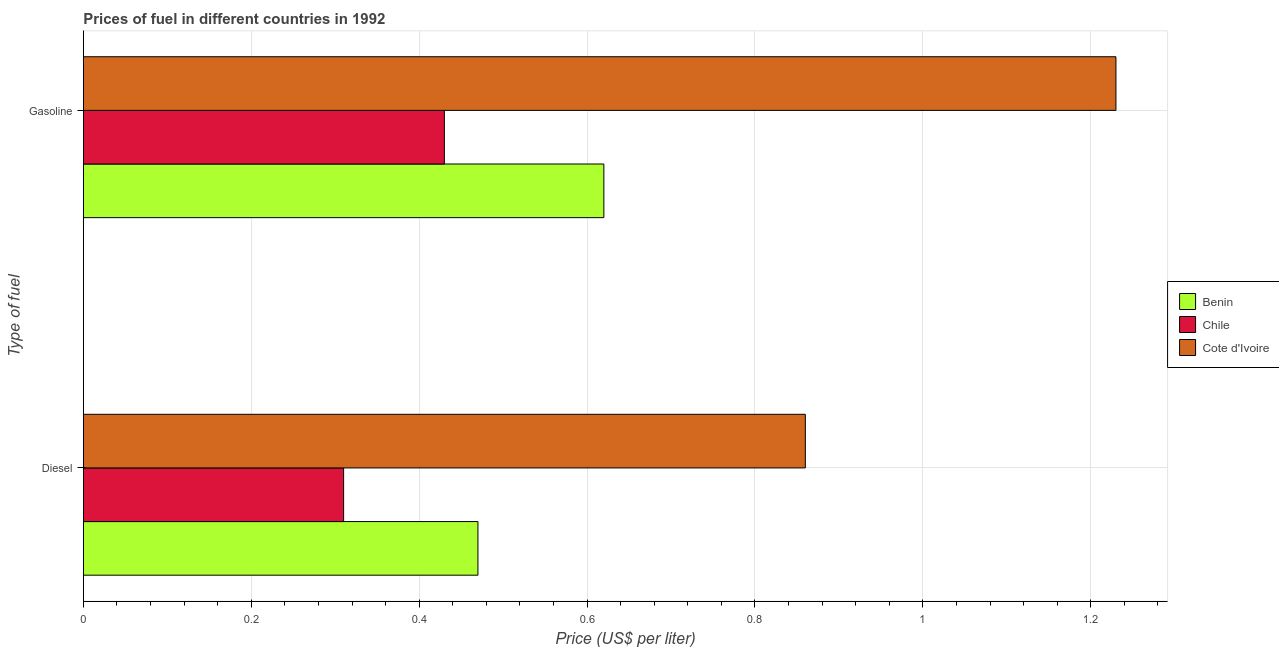How many groups of bars are there?
Make the answer very short. 2. Are the number of bars per tick equal to the number of legend labels?
Your answer should be very brief. Yes. Are the number of bars on each tick of the Y-axis equal?
Provide a succinct answer. Yes. How many bars are there on the 1st tick from the top?
Your response must be concise. 3. How many bars are there on the 1st tick from the bottom?
Give a very brief answer. 3. What is the label of the 1st group of bars from the top?
Provide a succinct answer. Gasoline. What is the gasoline price in Benin?
Provide a short and direct response. 0.62. Across all countries, what is the maximum diesel price?
Offer a terse response. 0.86. Across all countries, what is the minimum diesel price?
Offer a very short reply. 0.31. In which country was the gasoline price maximum?
Make the answer very short. Cote d'Ivoire. In which country was the diesel price minimum?
Offer a terse response. Chile. What is the total diesel price in the graph?
Keep it short and to the point. 1.64. What is the difference between the diesel price in Chile and that in Cote d'Ivoire?
Give a very brief answer. -0.55. What is the difference between the diesel price in Benin and the gasoline price in Chile?
Your response must be concise. 0.04. What is the average gasoline price per country?
Offer a very short reply. 0.76. What is the difference between the diesel price and gasoline price in Benin?
Offer a terse response. -0.15. In how many countries, is the gasoline price greater than 1 US$ per litre?
Give a very brief answer. 1. What is the ratio of the gasoline price in Benin to that in Chile?
Make the answer very short. 1.44. In how many countries, is the gasoline price greater than the average gasoline price taken over all countries?
Give a very brief answer. 1. What does the 3rd bar from the top in Diesel represents?
Provide a short and direct response. Benin. What does the 2nd bar from the bottom in Diesel represents?
Offer a very short reply. Chile. Are all the bars in the graph horizontal?
Make the answer very short. Yes. How many countries are there in the graph?
Give a very brief answer. 3. What is the difference between two consecutive major ticks on the X-axis?
Give a very brief answer. 0.2. Does the graph contain grids?
Offer a very short reply. Yes. How many legend labels are there?
Provide a succinct answer. 3. How are the legend labels stacked?
Offer a terse response. Vertical. What is the title of the graph?
Your answer should be compact. Prices of fuel in different countries in 1992. Does "Morocco" appear as one of the legend labels in the graph?
Make the answer very short. No. What is the label or title of the X-axis?
Make the answer very short. Price (US$ per liter). What is the label or title of the Y-axis?
Offer a very short reply. Type of fuel. What is the Price (US$ per liter) of Benin in Diesel?
Provide a short and direct response. 0.47. What is the Price (US$ per liter) in Chile in Diesel?
Make the answer very short. 0.31. What is the Price (US$ per liter) of Cote d'Ivoire in Diesel?
Make the answer very short. 0.86. What is the Price (US$ per liter) of Benin in Gasoline?
Keep it short and to the point. 0.62. What is the Price (US$ per liter) in Chile in Gasoline?
Offer a terse response. 0.43. What is the Price (US$ per liter) in Cote d'Ivoire in Gasoline?
Make the answer very short. 1.23. Across all Type of fuel, what is the maximum Price (US$ per liter) in Benin?
Your answer should be compact. 0.62. Across all Type of fuel, what is the maximum Price (US$ per liter) in Chile?
Make the answer very short. 0.43. Across all Type of fuel, what is the maximum Price (US$ per liter) of Cote d'Ivoire?
Keep it short and to the point. 1.23. Across all Type of fuel, what is the minimum Price (US$ per liter) of Benin?
Offer a very short reply. 0.47. Across all Type of fuel, what is the minimum Price (US$ per liter) of Chile?
Provide a short and direct response. 0.31. Across all Type of fuel, what is the minimum Price (US$ per liter) of Cote d'Ivoire?
Keep it short and to the point. 0.86. What is the total Price (US$ per liter) in Benin in the graph?
Keep it short and to the point. 1.09. What is the total Price (US$ per liter) in Chile in the graph?
Give a very brief answer. 0.74. What is the total Price (US$ per liter) in Cote d'Ivoire in the graph?
Offer a terse response. 2.09. What is the difference between the Price (US$ per liter) of Chile in Diesel and that in Gasoline?
Provide a short and direct response. -0.12. What is the difference between the Price (US$ per liter) in Cote d'Ivoire in Diesel and that in Gasoline?
Your answer should be very brief. -0.37. What is the difference between the Price (US$ per liter) in Benin in Diesel and the Price (US$ per liter) in Chile in Gasoline?
Keep it short and to the point. 0.04. What is the difference between the Price (US$ per liter) in Benin in Diesel and the Price (US$ per liter) in Cote d'Ivoire in Gasoline?
Your response must be concise. -0.76. What is the difference between the Price (US$ per liter) in Chile in Diesel and the Price (US$ per liter) in Cote d'Ivoire in Gasoline?
Your answer should be very brief. -0.92. What is the average Price (US$ per liter) of Benin per Type of fuel?
Your response must be concise. 0.55. What is the average Price (US$ per liter) of Chile per Type of fuel?
Keep it short and to the point. 0.37. What is the average Price (US$ per liter) in Cote d'Ivoire per Type of fuel?
Provide a short and direct response. 1.04. What is the difference between the Price (US$ per liter) in Benin and Price (US$ per liter) in Chile in Diesel?
Offer a very short reply. 0.16. What is the difference between the Price (US$ per liter) of Benin and Price (US$ per liter) of Cote d'Ivoire in Diesel?
Give a very brief answer. -0.39. What is the difference between the Price (US$ per liter) of Chile and Price (US$ per liter) of Cote d'Ivoire in Diesel?
Make the answer very short. -0.55. What is the difference between the Price (US$ per liter) in Benin and Price (US$ per liter) in Chile in Gasoline?
Your response must be concise. 0.19. What is the difference between the Price (US$ per liter) of Benin and Price (US$ per liter) of Cote d'Ivoire in Gasoline?
Your response must be concise. -0.61. What is the difference between the Price (US$ per liter) of Chile and Price (US$ per liter) of Cote d'Ivoire in Gasoline?
Keep it short and to the point. -0.8. What is the ratio of the Price (US$ per liter) of Benin in Diesel to that in Gasoline?
Your answer should be very brief. 0.76. What is the ratio of the Price (US$ per liter) of Chile in Diesel to that in Gasoline?
Offer a very short reply. 0.72. What is the ratio of the Price (US$ per liter) in Cote d'Ivoire in Diesel to that in Gasoline?
Keep it short and to the point. 0.7. What is the difference between the highest and the second highest Price (US$ per liter) of Chile?
Your answer should be compact. 0.12. What is the difference between the highest and the second highest Price (US$ per liter) in Cote d'Ivoire?
Offer a terse response. 0.37. What is the difference between the highest and the lowest Price (US$ per liter) in Benin?
Keep it short and to the point. 0.15. What is the difference between the highest and the lowest Price (US$ per liter) of Chile?
Provide a succinct answer. 0.12. What is the difference between the highest and the lowest Price (US$ per liter) in Cote d'Ivoire?
Your response must be concise. 0.37. 